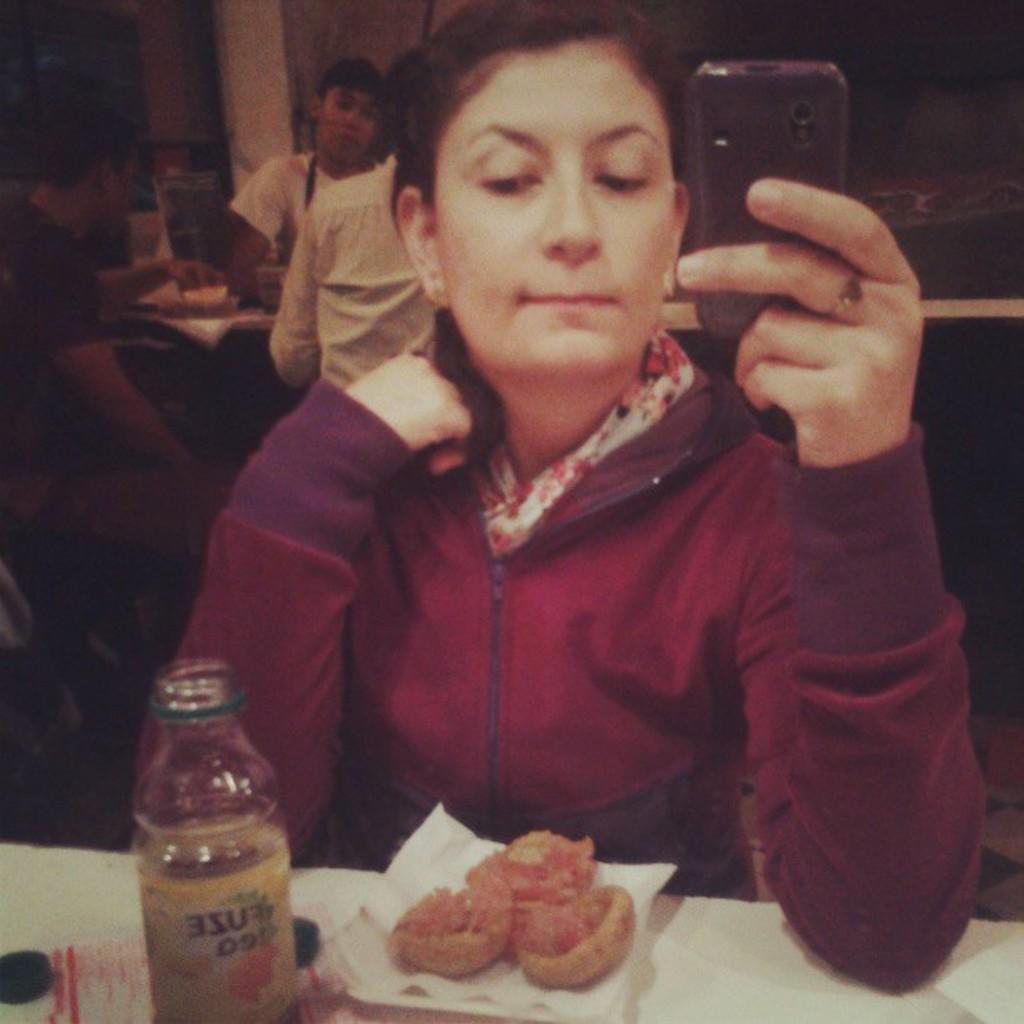Who is the main subject in the image? There is a woman in the image. What is the woman doing in the image? The woman is seated. What object is the woman holding in her hand? The woman is holding a mobile in her hand. What can be seen on the table in the image? There is a water bottle and food on the table. What is the size of the school in the image? There is no school present in the image. 